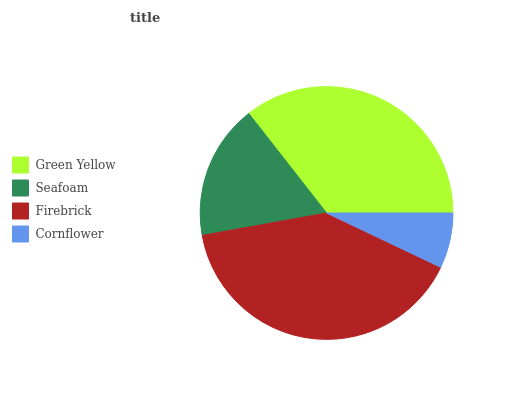Is Cornflower the minimum?
Answer yes or no. Yes. Is Firebrick the maximum?
Answer yes or no. Yes. Is Seafoam the minimum?
Answer yes or no. No. Is Seafoam the maximum?
Answer yes or no. No. Is Green Yellow greater than Seafoam?
Answer yes or no. Yes. Is Seafoam less than Green Yellow?
Answer yes or no. Yes. Is Seafoam greater than Green Yellow?
Answer yes or no. No. Is Green Yellow less than Seafoam?
Answer yes or no. No. Is Green Yellow the high median?
Answer yes or no. Yes. Is Seafoam the low median?
Answer yes or no. Yes. Is Seafoam the high median?
Answer yes or no. No. Is Cornflower the low median?
Answer yes or no. No. 